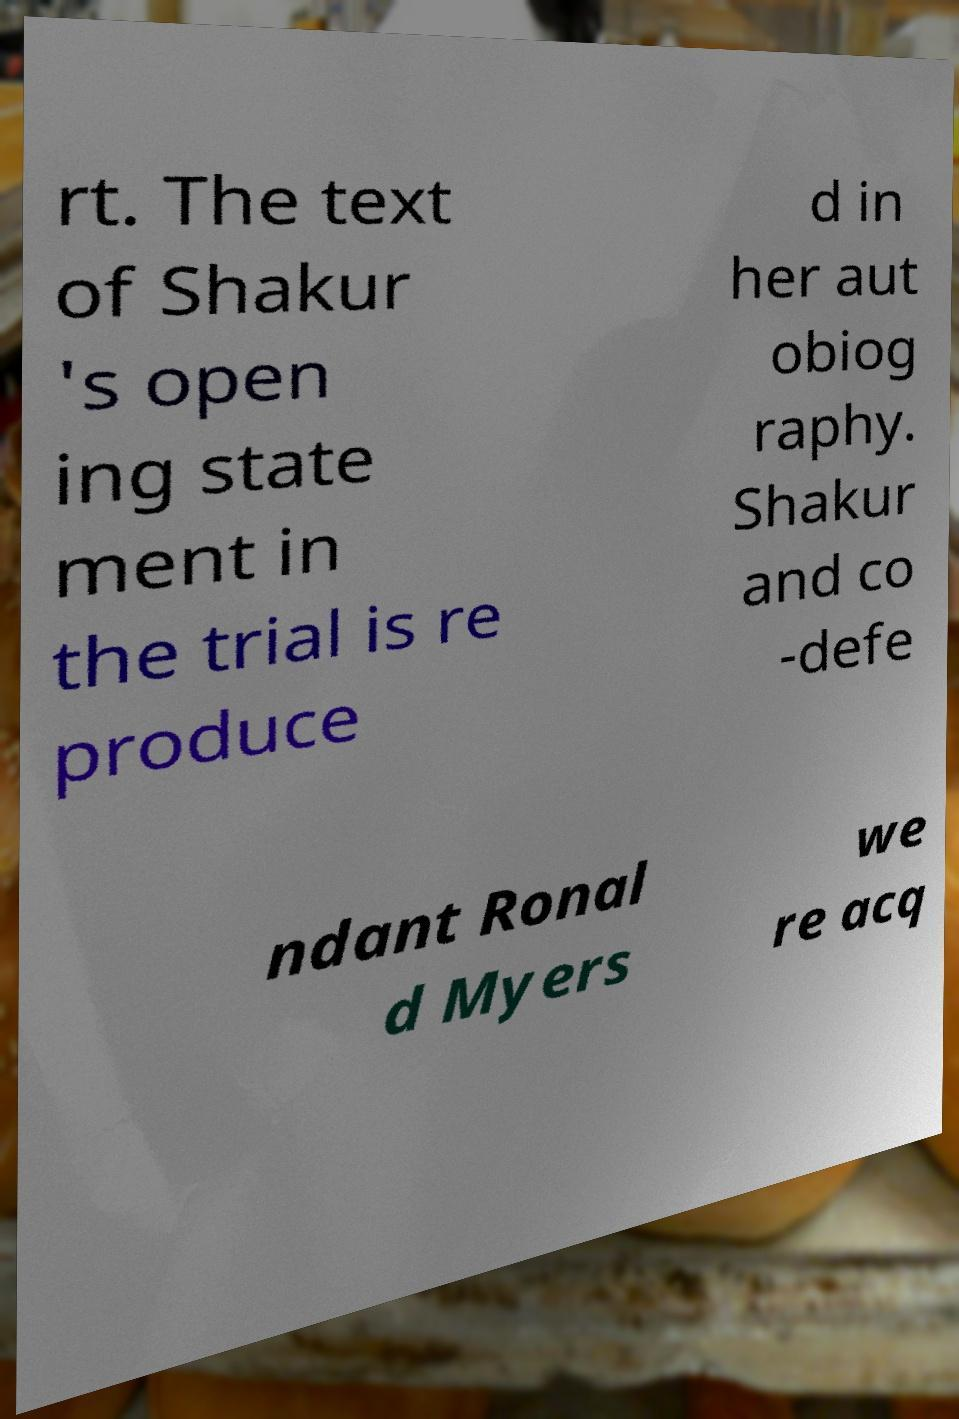Could you assist in decoding the text presented in this image and type it out clearly? rt. The text of Shakur 's open ing state ment in the trial is re produce d in her aut obiog raphy. Shakur and co -defe ndant Ronal d Myers we re acq 